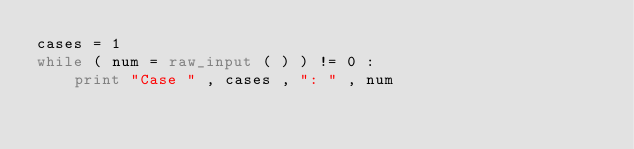<code> <loc_0><loc_0><loc_500><loc_500><_Python_>cases = 1
while ( num = raw_input ( ) ) != 0 :
    print "Case " , cases , ": " , num</code> 